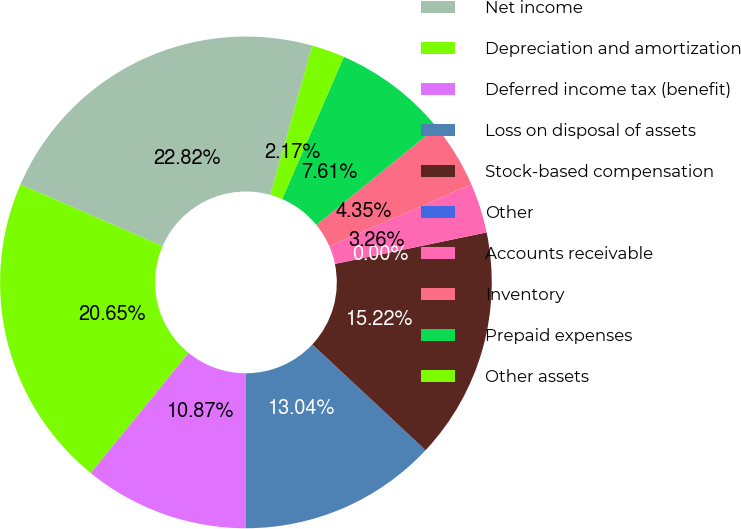Convert chart. <chart><loc_0><loc_0><loc_500><loc_500><pie_chart><fcel>Net income<fcel>Depreciation and amortization<fcel>Deferred income tax (benefit)<fcel>Loss on disposal of assets<fcel>Stock-based compensation<fcel>Other<fcel>Accounts receivable<fcel>Inventory<fcel>Prepaid expenses<fcel>Other assets<nl><fcel>22.82%<fcel>20.65%<fcel>10.87%<fcel>13.04%<fcel>15.22%<fcel>0.0%<fcel>3.26%<fcel>4.35%<fcel>7.61%<fcel>2.17%<nl></chart> 